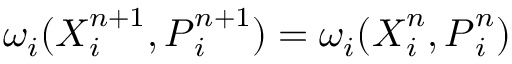Convert formula to latex. <formula><loc_0><loc_0><loc_500><loc_500>\omega _ { i } ( { X } _ { i } ^ { n + 1 } , { P } _ { i } ^ { n + 1 } ) = \omega _ { i } ( { X } _ { i } ^ { n } , { P } _ { i } ^ { n } )</formula> 